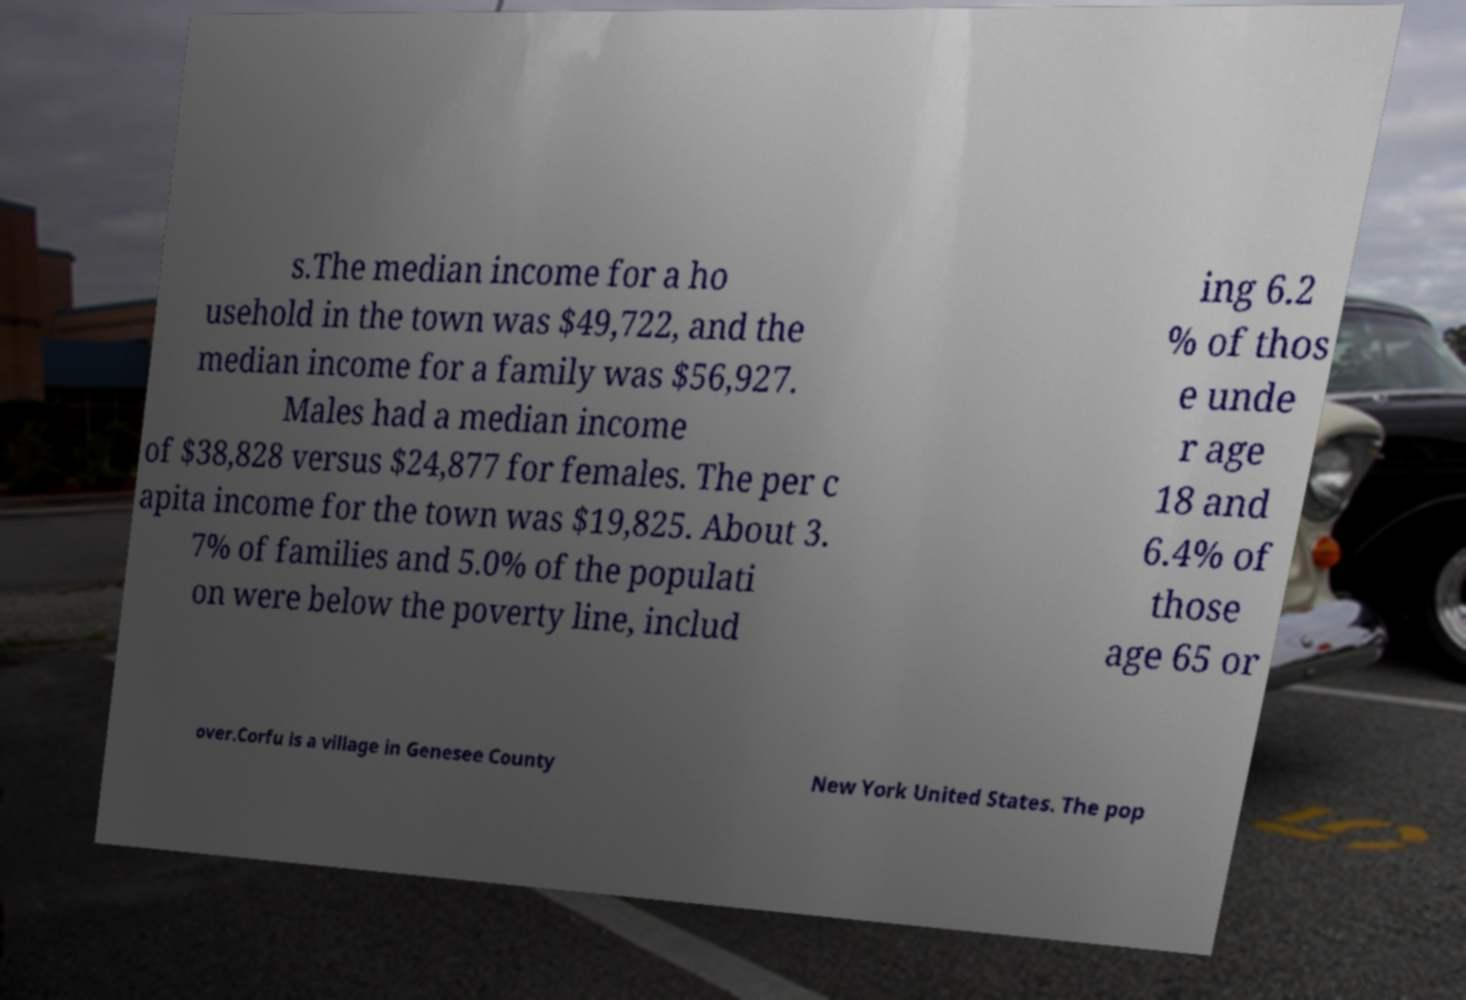There's text embedded in this image that I need extracted. Can you transcribe it verbatim? s.The median income for a ho usehold in the town was $49,722, and the median income for a family was $56,927. Males had a median income of $38,828 versus $24,877 for females. The per c apita income for the town was $19,825. About 3. 7% of families and 5.0% of the populati on were below the poverty line, includ ing 6.2 % of thos e unde r age 18 and 6.4% of those age 65 or over.Corfu is a village in Genesee County New York United States. The pop 